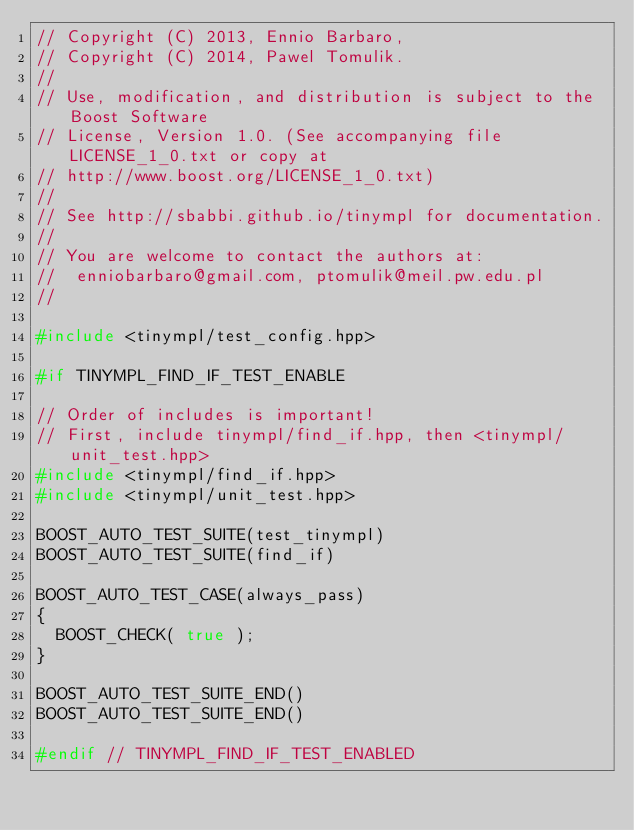<code> <loc_0><loc_0><loc_500><loc_500><_C++_>// Copyright (C) 2013, Ennio Barbaro,
// Copyright (C) 2014, Pawel Tomulik.
//
// Use, modification, and distribution is subject to the Boost Software
// License, Version 1.0. (See accompanying file LICENSE_1_0.txt or copy at
// http://www.boost.org/LICENSE_1_0.txt)
//
// See http://sbabbi.github.io/tinympl for documentation.
//
// You are welcome to contact the authors at:
//  enniobarbaro@gmail.com, ptomulik@meil.pw.edu.pl
//

#include <tinympl/test_config.hpp>

#if TINYMPL_FIND_IF_TEST_ENABLE

// Order of includes is important!
// First, include tinympl/find_if.hpp, then <tinympl/unit_test.hpp>
#include <tinympl/find_if.hpp>
#include <tinympl/unit_test.hpp>

BOOST_AUTO_TEST_SUITE(test_tinympl)
BOOST_AUTO_TEST_SUITE(find_if)

BOOST_AUTO_TEST_CASE(always_pass)
{
  BOOST_CHECK( true );
}

BOOST_AUTO_TEST_SUITE_END()
BOOST_AUTO_TEST_SUITE_END()

#endif // TINYMPL_FIND_IF_TEST_ENABLED
</code> 